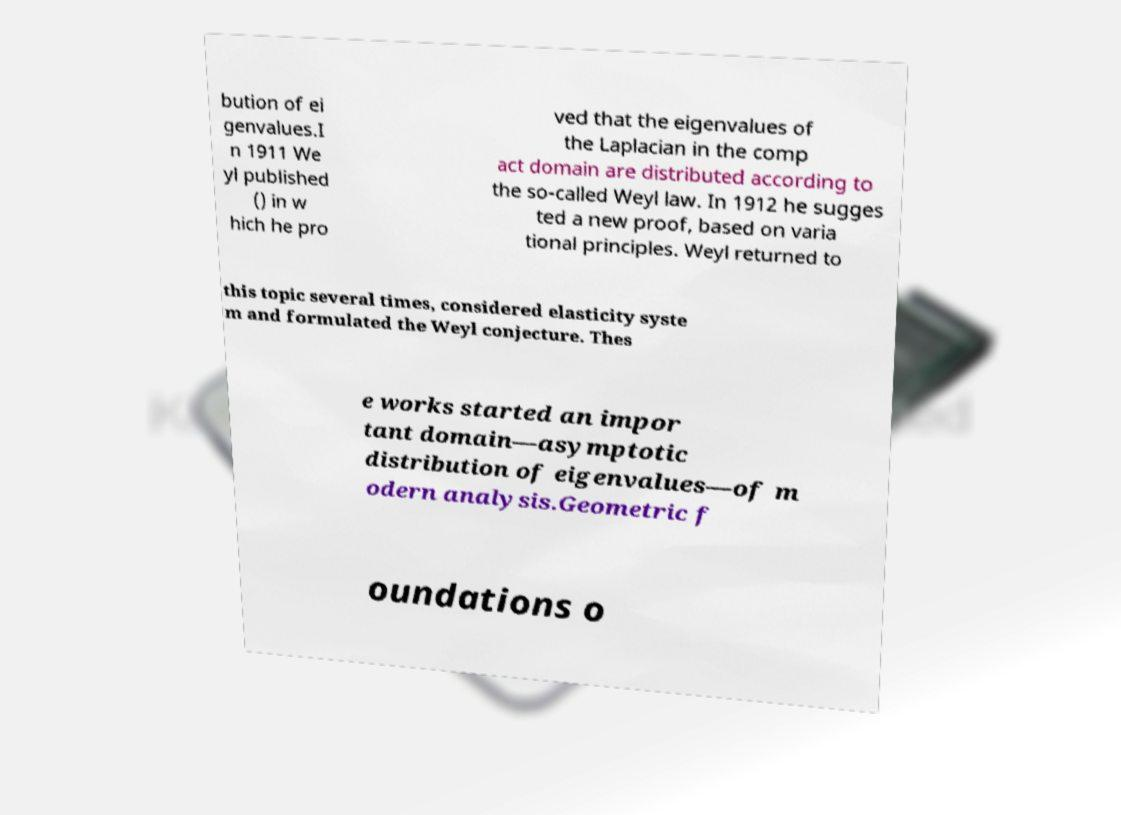Could you extract and type out the text from this image? bution of ei genvalues.I n 1911 We yl published () in w hich he pro ved that the eigenvalues of the Laplacian in the comp act domain are distributed according to the so-called Weyl law. In 1912 he sugges ted a new proof, based on varia tional principles. Weyl returned to this topic several times, considered elasticity syste m and formulated the Weyl conjecture. Thes e works started an impor tant domain—asymptotic distribution of eigenvalues—of m odern analysis.Geometric f oundations o 